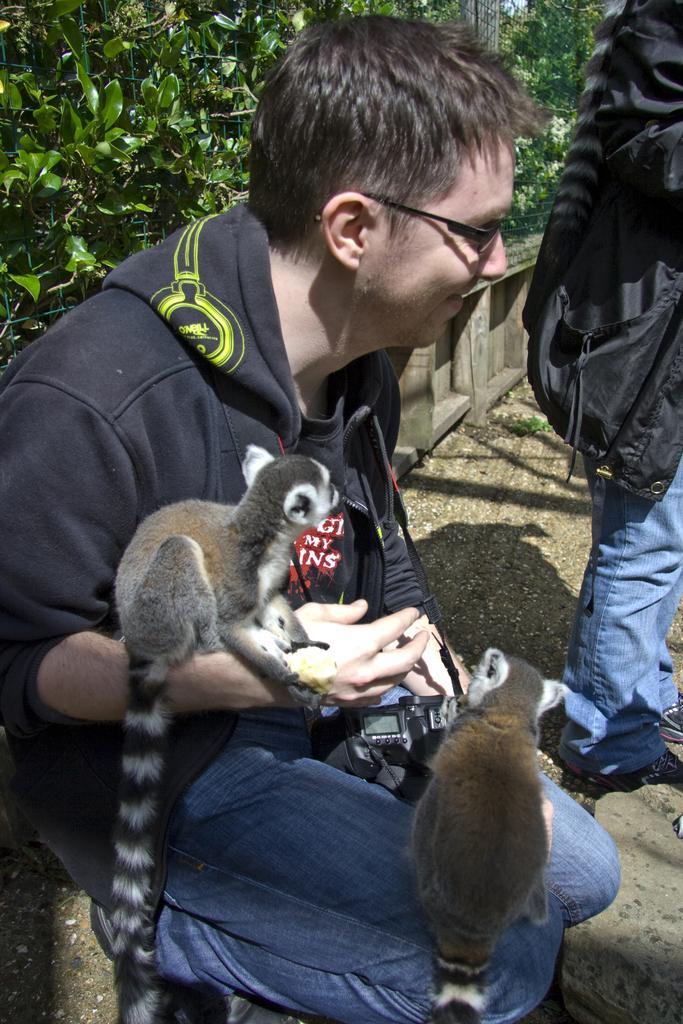In one or two sentences, can you explain what this image depicts? In the image there is a man with spectacles is holding a camera. And there are two animals on him. On the right corner of the image there is a person standing and on him there is a tail. In the background there are leaves. 